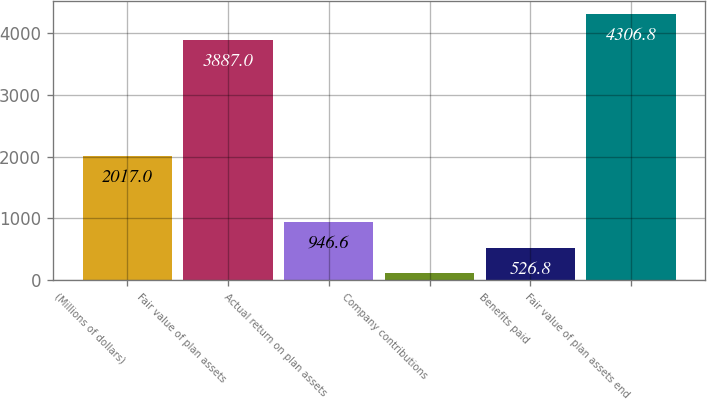Convert chart to OTSL. <chart><loc_0><loc_0><loc_500><loc_500><bar_chart><fcel>(Millions of dollars)<fcel>Fair value of plan assets<fcel>Actual return on plan assets<fcel>Company contributions<fcel>Benefits paid<fcel>Fair value of plan assets end<nl><fcel>2017<fcel>3887<fcel>946.6<fcel>107<fcel>526.8<fcel>4306.8<nl></chart> 